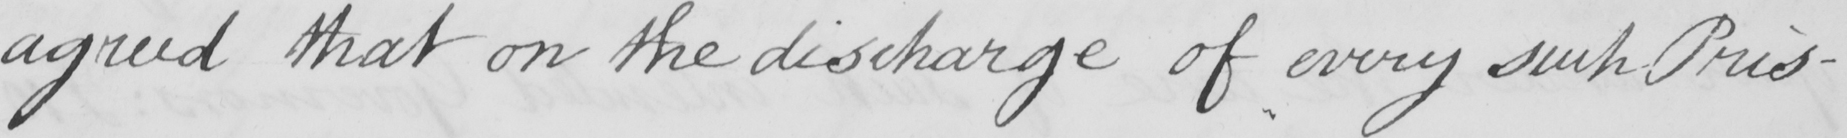Can you tell me what this handwritten text says? agreed that on the discharge of every such Pris- 